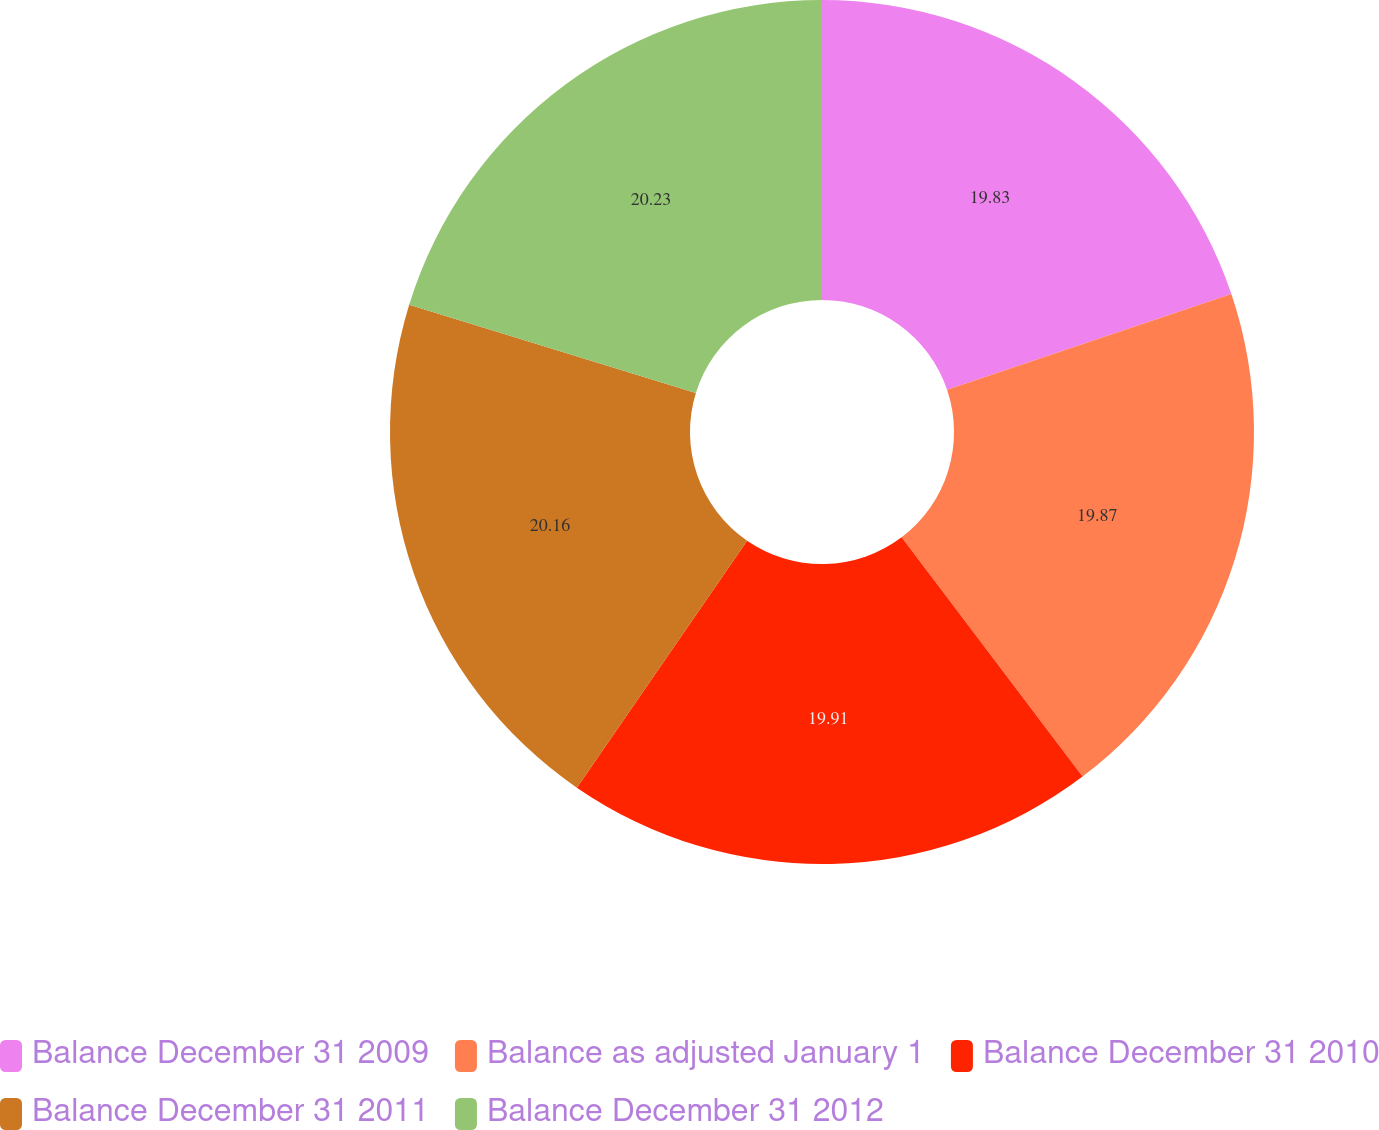Convert chart to OTSL. <chart><loc_0><loc_0><loc_500><loc_500><pie_chart><fcel>Balance December 31 2009<fcel>Balance as adjusted January 1<fcel>Balance December 31 2010<fcel>Balance December 31 2011<fcel>Balance December 31 2012<nl><fcel>19.83%<fcel>19.87%<fcel>19.91%<fcel>20.16%<fcel>20.24%<nl></chart> 